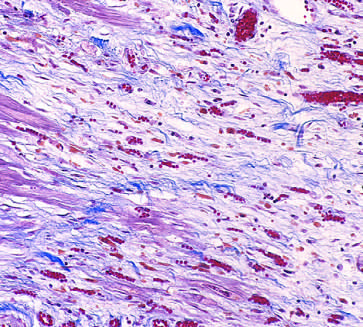how is granulation tissue characterized?
Answer the question using a single word or phrase. By loose connective and abundant capillaries 